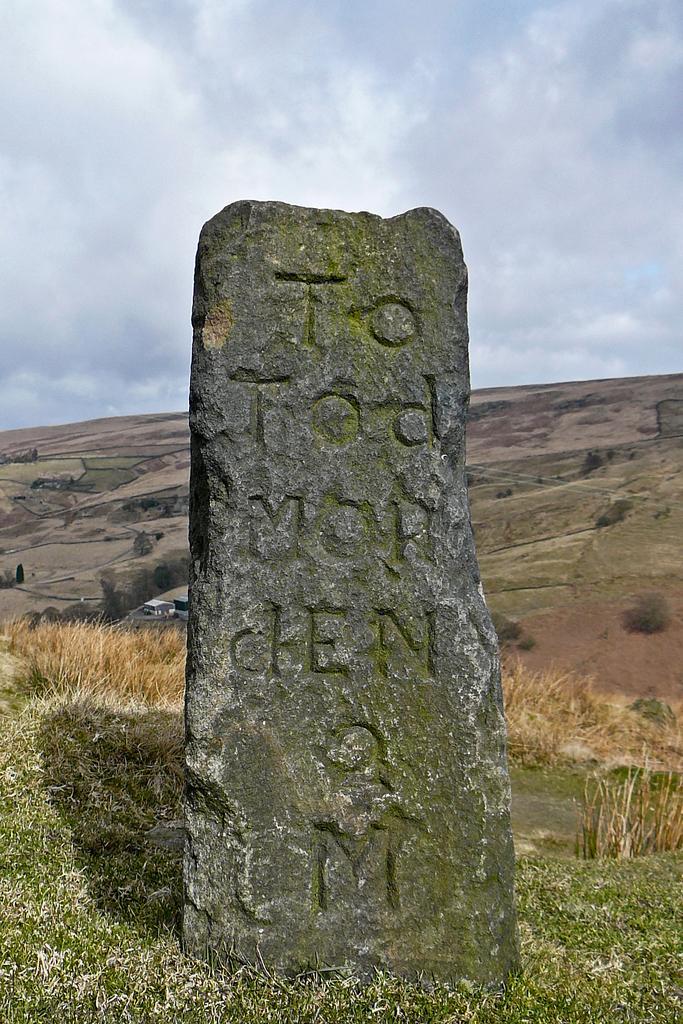In one or two sentences, can you explain what this image depicts? In the center of the image there is a lay stone. In the background there is a hill and sky. At the bottom there is grass. 